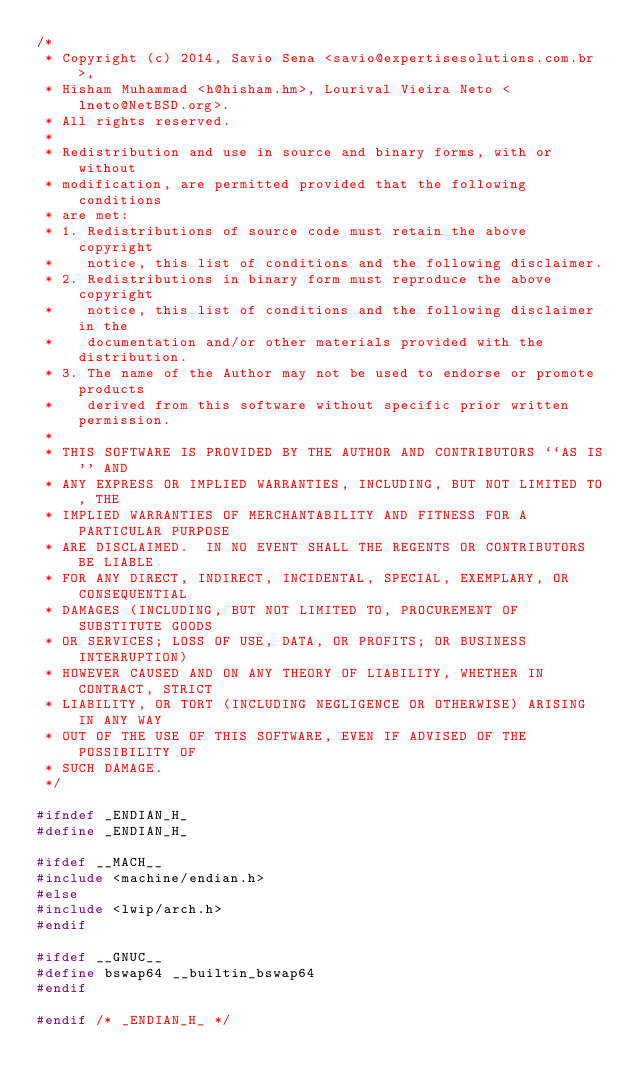<code> <loc_0><loc_0><loc_500><loc_500><_C_>/*
 * Copyright (c) 2014, Savio Sena <savio@expertisesolutions.com.br>,
 * Hisham Muhammad <h@hisham.hm>, Lourival Vieira Neto <lneto@NetBSD.org>.
 * All rights reserved.
 *
 * Redistribution and use in source and binary forms, with or without
 * modification, are permitted provided that the following conditions
 * are met:
 * 1. Redistributions of source code must retain the above copyright
 *    notice, this list of conditions and the following disclaimer.
 * 2. Redistributions in binary form must reproduce the above copyright
 *    notice, this list of conditions and the following disclaimer in the
 *    documentation and/or other materials provided with the distribution.
 * 3. The name of the Author may not be used to endorse or promote products
 *    derived from this software without specific prior written permission.
 *
 * THIS SOFTWARE IS PROVIDED BY THE AUTHOR AND CONTRIBUTORS ``AS IS'' AND
 * ANY EXPRESS OR IMPLIED WARRANTIES, INCLUDING, BUT NOT LIMITED TO, THE
 * IMPLIED WARRANTIES OF MERCHANTABILITY AND FITNESS FOR A PARTICULAR PURPOSE
 * ARE DISCLAIMED.  IN NO EVENT SHALL THE REGENTS OR CONTRIBUTORS BE LIABLE
 * FOR ANY DIRECT, INDIRECT, INCIDENTAL, SPECIAL, EXEMPLARY, OR CONSEQUENTIAL
 * DAMAGES (INCLUDING, BUT NOT LIMITED TO, PROCUREMENT OF SUBSTITUTE GOODS
 * OR SERVICES; LOSS OF USE, DATA, OR PROFITS; OR BUSINESS INTERRUPTION)
 * HOWEVER CAUSED AND ON ANY THEORY OF LIABILITY, WHETHER IN CONTRACT, STRICT
 * LIABILITY, OR TORT (INCLUDING NEGLIGENCE OR OTHERWISE) ARISING IN ANY WAY
 * OUT OF THE USE OF THIS SOFTWARE, EVEN IF ADVISED OF THE POSSIBILITY OF
 * SUCH DAMAGE.
 */

#ifndef _ENDIAN_H_
#define _ENDIAN_H_

#ifdef __MACH__
#include <machine/endian.h>
#else
#include <lwip/arch.h>
#endif

#ifdef __GNUC__
#define bswap64 __builtin_bswap64
#endif

#endif /* _ENDIAN_H_ */</code> 